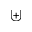<formula> <loc_0><loc_0><loc_500><loc_500>\uplus</formula> 